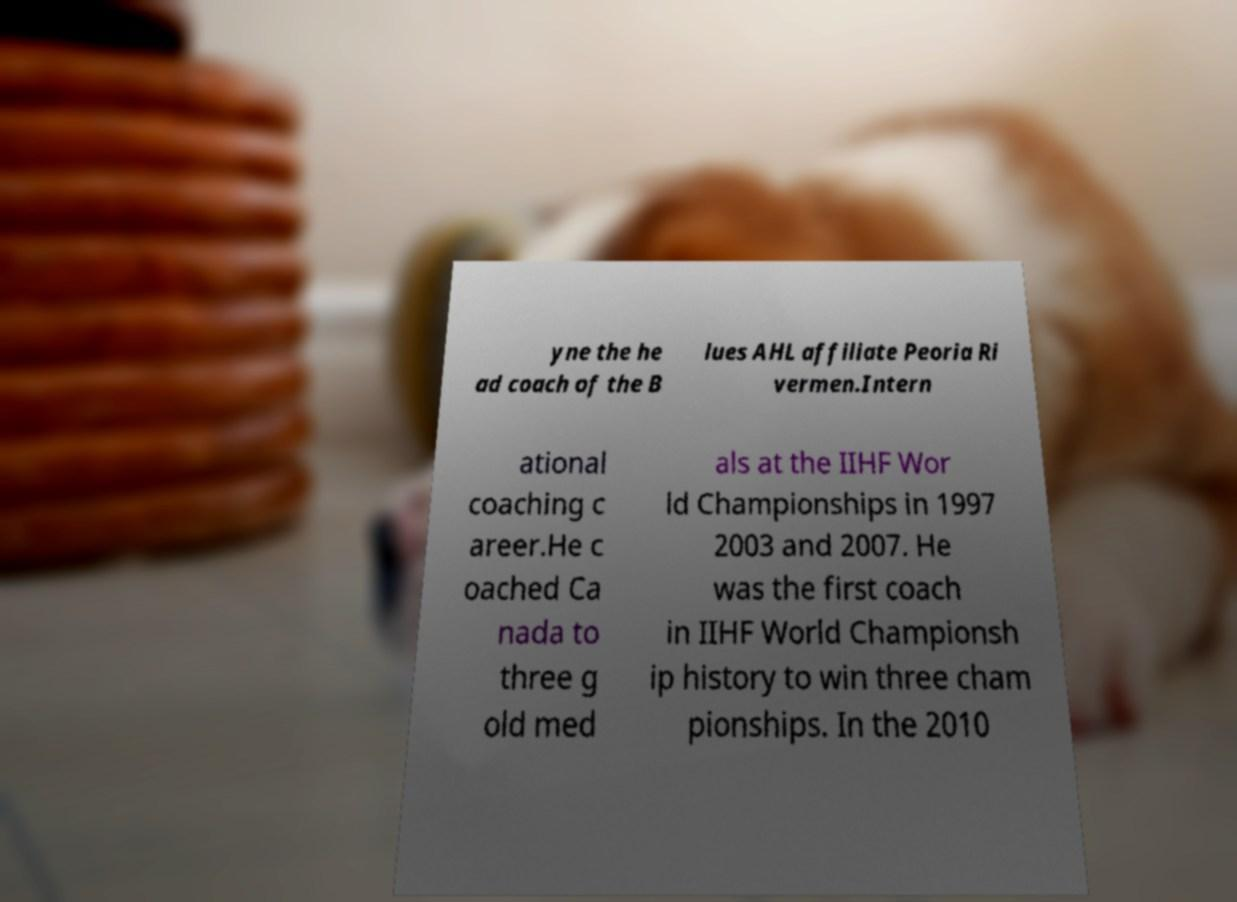Please read and relay the text visible in this image. What does it say? yne the he ad coach of the B lues AHL affiliate Peoria Ri vermen.Intern ational coaching c areer.He c oached Ca nada to three g old med als at the IIHF Wor ld Championships in 1997 2003 and 2007. He was the first coach in IIHF World Championsh ip history to win three cham pionships. In the 2010 